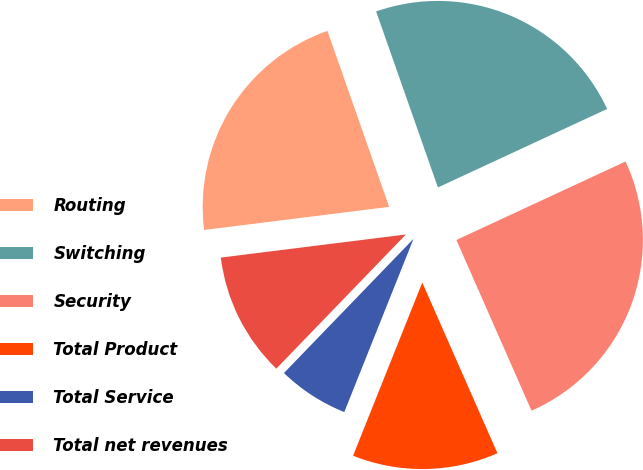<chart> <loc_0><loc_0><loc_500><loc_500><pie_chart><fcel>Routing<fcel>Switching<fcel>Security<fcel>Total Product<fcel>Total Service<fcel>Total net revenues<nl><fcel>21.6%<fcel>23.46%<fcel>25.31%<fcel>12.65%<fcel>6.17%<fcel>10.8%<nl></chart> 